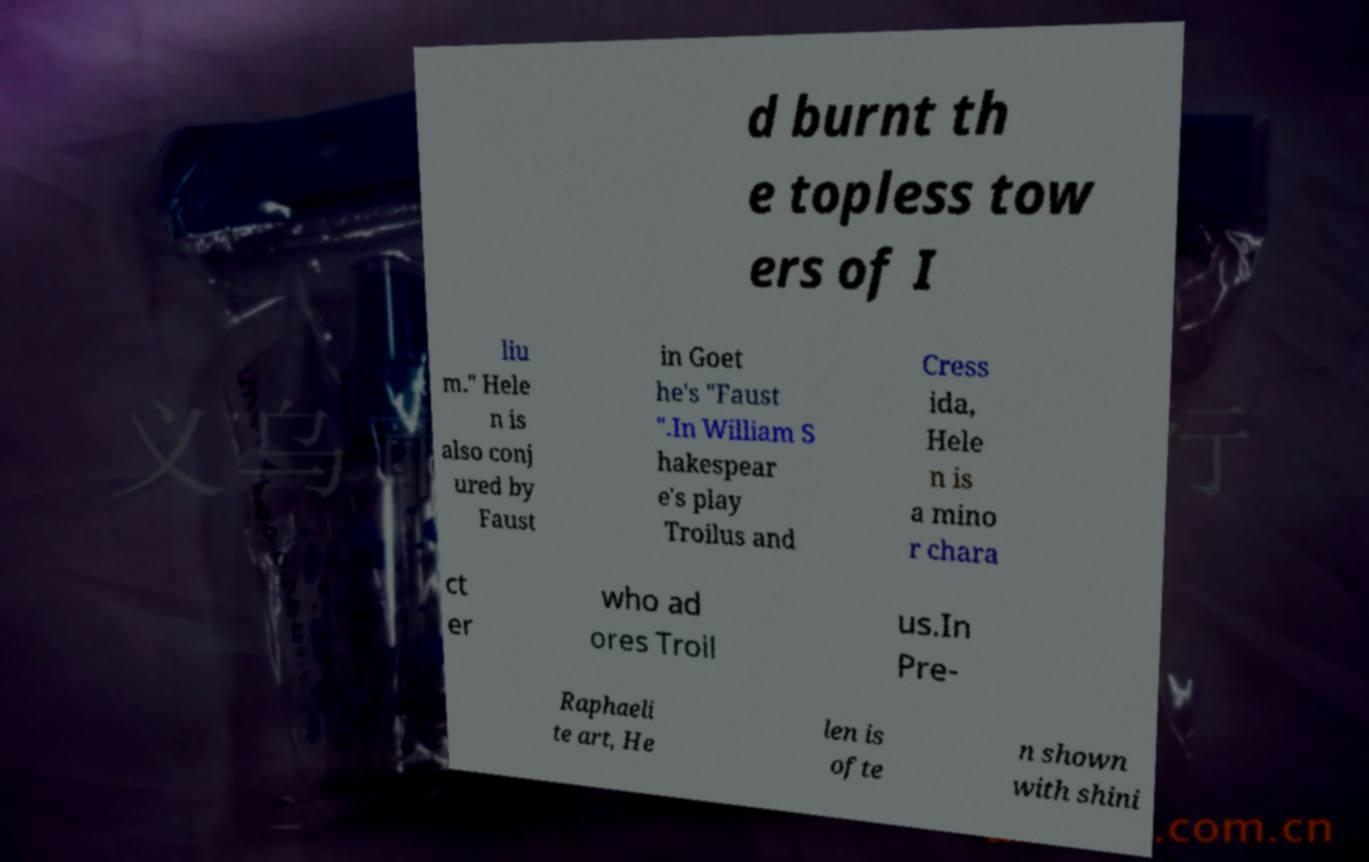What messages or text are displayed in this image? I need them in a readable, typed format. d burnt th e topless tow ers of I liu m." Hele n is also conj ured by Faust in Goet he's "Faust ".In William S hakespear e's play Troilus and Cress ida, Hele n is a mino r chara ct er who ad ores Troil us.In Pre- Raphaeli te art, He len is ofte n shown with shini 